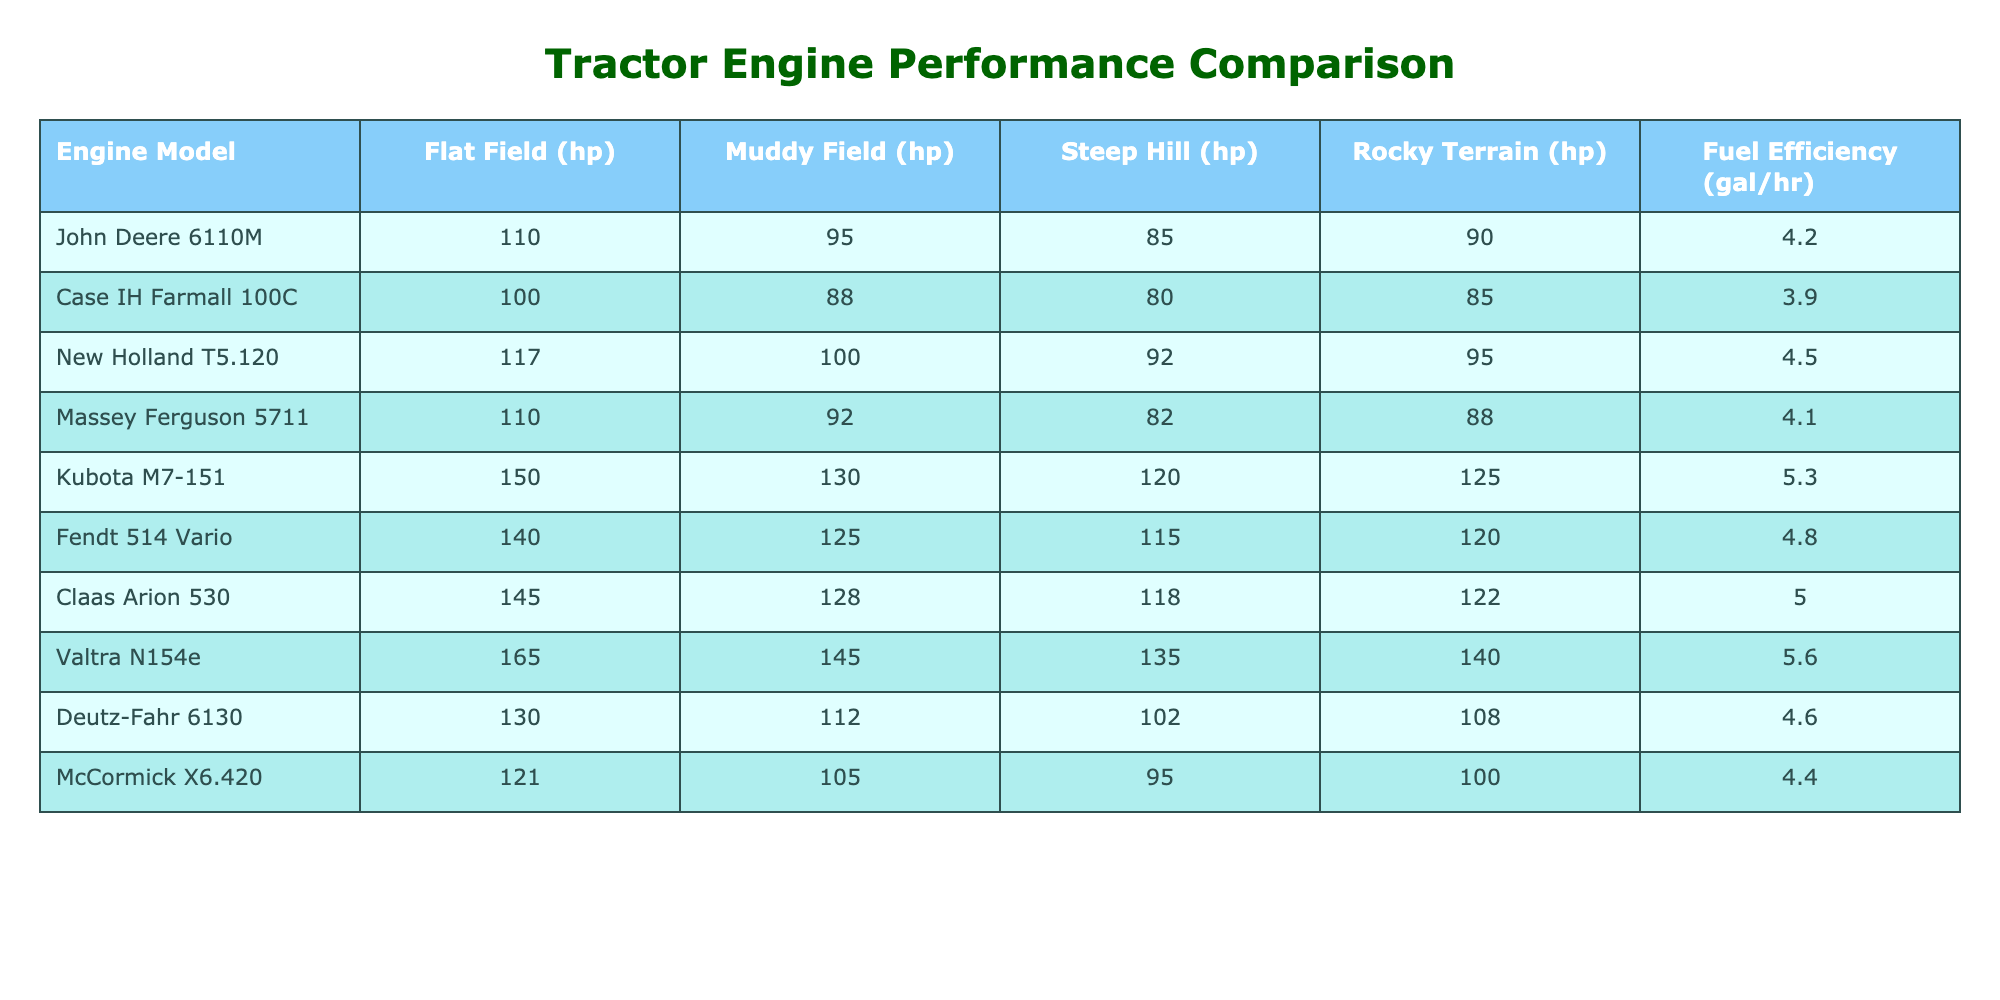What is the fuel efficiency of the Kubota M7-151? The table shows that the fuel efficiency column for Kubota M7-151 is listed as 5.3 gallons per hour.
Answer: 5.3 Which engine model has the highest horsepower in muddy field conditions? By comparing the muddy field horsepower values across all models, Valtra N154e has 145 hp, which is the highest among all models.
Answer: Valtra N154e What is the difference in horsepower between the New Holland T5.120 and the Case IH Farmall 100C on a flat field? The horsepower for New Holland T5.120 on a flat field is 117 hp, while Case IH Farmall 100C has 100 hp. The difference is calculated as 117 - 100 = 17 hp.
Answer: 17 hp What is the average horsepower achieved on steep hills across all models? To find the average, we sum all steep hill horsepower values: 85 + 80 + 92 + 82 + 120 + 115 + 118 + 135 + 102 + 95 = 1077. There are 10 models, so the average is 1077 / 10 = 107.7 hp.
Answer: 107.7 hp Is the fuel efficiency of the Fendt 514 Vario greater than 4.5 gallons per hour? The table states that the fuel efficiency of Fendt 514 Vario is 4.8 gallons per hour, which is greater than 4.5. Therefore, the answer is yes.
Answer: Yes Which engine model performs best in rocky terrain based on horsepower? Comparing rocky terrain horsepower, Valtra N154e has the highest performance with 140 hp, making it the best-performing model in this category.
Answer: Valtra N154e What is the total horsepower for the Deutz-Fahr 6130 across all conditions? We sum the horsepower values for Deutz-Fahr 6130: 130 (flat) + 112 (muddy) + 102 (steep) + 108 (rocky) = 452 hp total across all conditions.
Answer: 452 hp Which engine model has the lowest horsepower on flat fields? In the flat field category, the Case IH Farmall 100C has the lowest horsepower at 100 hp when compared to others.
Answer: Case IH Farmall 100C On which terrain condition does the Massey Ferguson 5711 perform worst, in terms of horsepower? The lowest horsepower value for Massey Ferguson 5711 is on steep hills with 82 hp, making this its worst performance terrain condition.
Answer: Steep Hill What is the range of horsepower across flat terrain for all models? The flat field performance ranges from 100 hp (lowest from Case IH Farmall 100C) to 165 hp (highest from Valtra N154e). The range is calculated as 165 - 100 = 65 hp.
Answer: 65 hp 